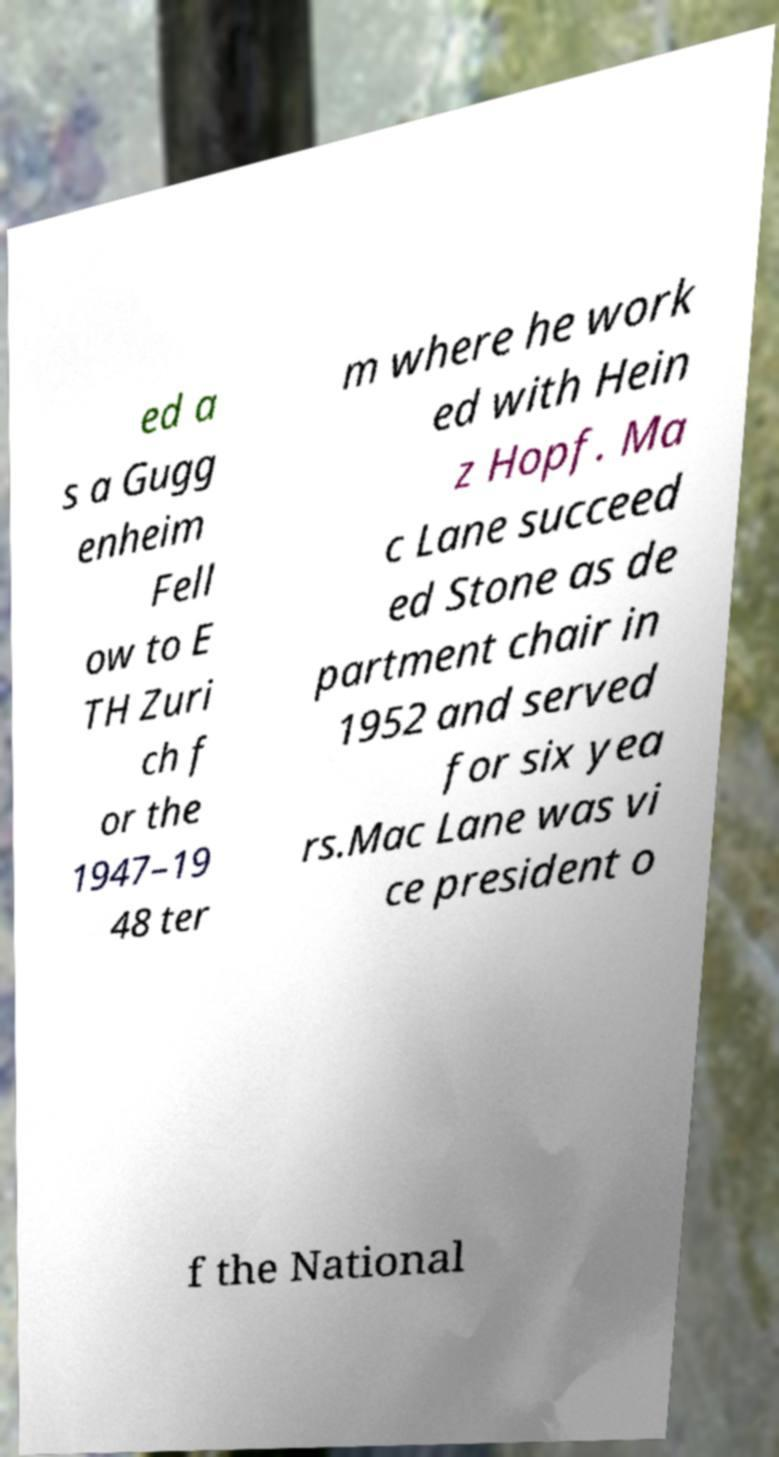Can you accurately transcribe the text from the provided image for me? ed a s a Gugg enheim Fell ow to E TH Zuri ch f or the 1947–19 48 ter m where he work ed with Hein z Hopf. Ma c Lane succeed ed Stone as de partment chair in 1952 and served for six yea rs.Mac Lane was vi ce president o f the National 